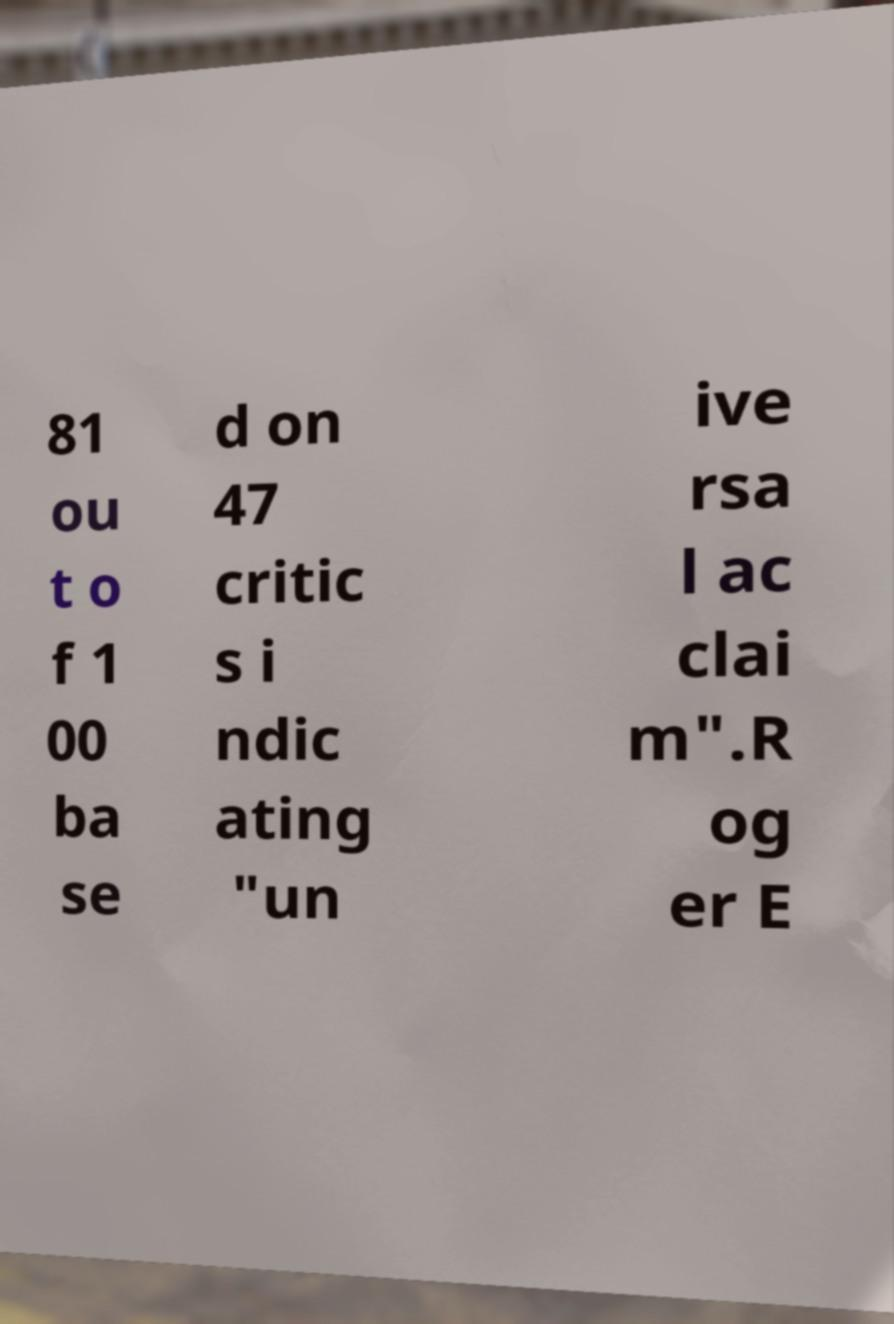What messages or text are displayed in this image? I need them in a readable, typed format. 81 ou t o f 1 00 ba se d on 47 critic s i ndic ating "un ive rsa l ac clai m".R og er E 